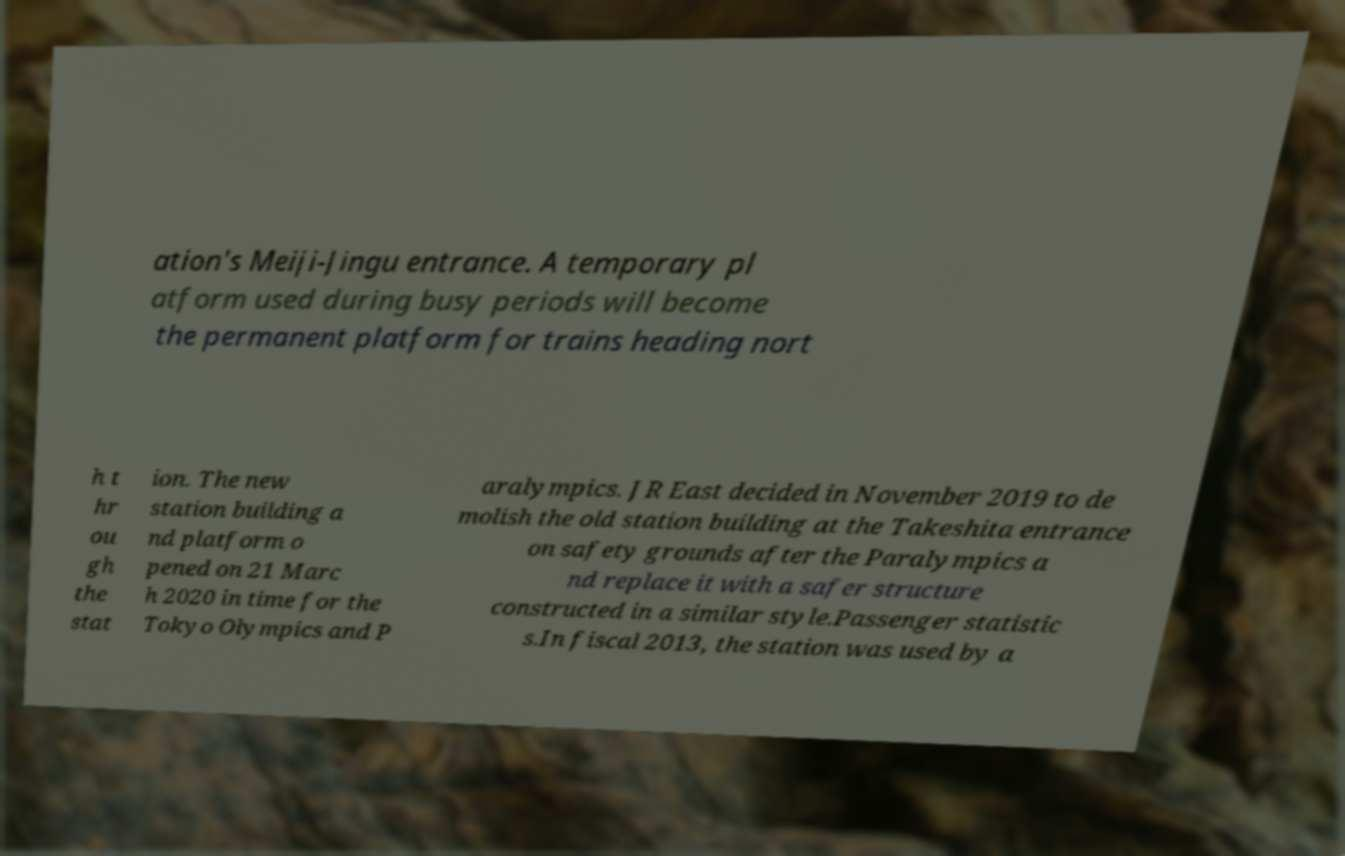What messages or text are displayed in this image? I need them in a readable, typed format. ation's Meiji-Jingu entrance. A temporary pl atform used during busy periods will become the permanent platform for trains heading nort h t hr ou gh the stat ion. The new station building a nd platform o pened on 21 Marc h 2020 in time for the Tokyo Olympics and P aralympics. JR East decided in November 2019 to de molish the old station building at the Takeshita entrance on safety grounds after the Paralympics a nd replace it with a safer structure constructed in a similar style.Passenger statistic s.In fiscal 2013, the station was used by a 